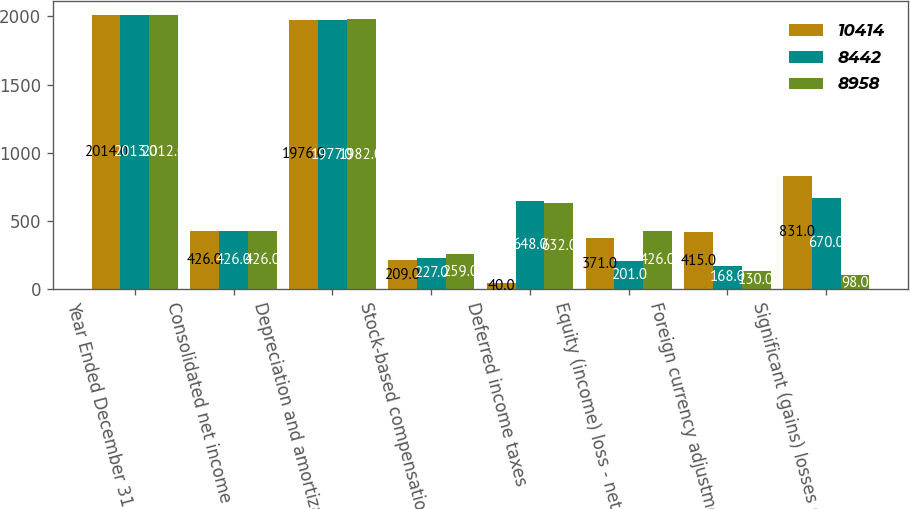Convert chart. <chart><loc_0><loc_0><loc_500><loc_500><stacked_bar_chart><ecel><fcel>Year Ended December 31<fcel>Consolidated net income<fcel>Depreciation and amortization<fcel>Stock-based compensation<fcel>Deferred income taxes<fcel>Equity (income) loss - net of<fcel>Foreign currency adjustments<fcel>Significant (gains) losses on<nl><fcel>10414<fcel>2014<fcel>426<fcel>1976<fcel>209<fcel>40<fcel>371<fcel>415<fcel>831<nl><fcel>8442<fcel>2013<fcel>426<fcel>1977<fcel>227<fcel>648<fcel>201<fcel>168<fcel>670<nl><fcel>8958<fcel>2012<fcel>426<fcel>1982<fcel>259<fcel>632<fcel>426<fcel>130<fcel>98<nl></chart> 